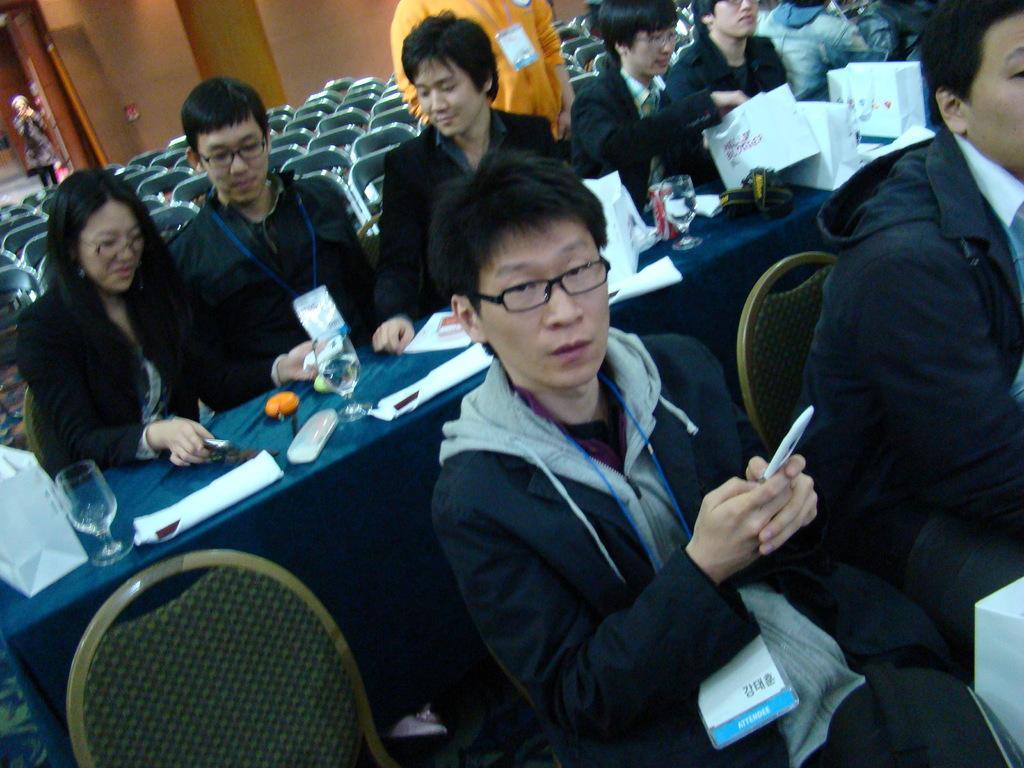Can you describe this image briefly? In this image there are few people sitting on their chairs, one of them is holding a mobile in his hand, in front of them there is a table with some stuff on it, behind there there are empty chairs. In the background there is a lady standing. 